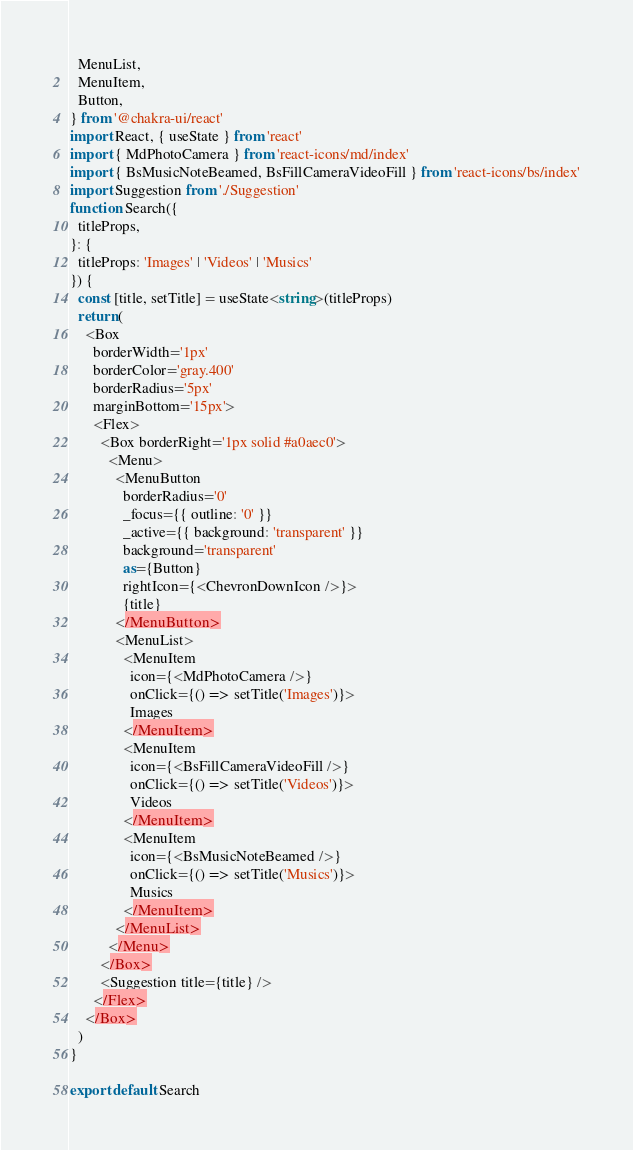<code> <loc_0><loc_0><loc_500><loc_500><_TypeScript_>  MenuList,
  MenuItem,
  Button,
} from '@chakra-ui/react'
import React, { useState } from 'react'
import { MdPhotoCamera } from 'react-icons/md/index'
import { BsMusicNoteBeamed, BsFillCameraVideoFill } from 'react-icons/bs/index'
import Suggestion from './Suggestion'
function Search({
  titleProps,
}: {
  titleProps: 'Images' | 'Videos' | 'Musics'
}) {
  const [title, setTitle] = useState<string>(titleProps)
  return (
    <Box
      borderWidth='1px'
      borderColor='gray.400'
      borderRadius='5px'
      marginBottom='15px'>
      <Flex>
        <Box borderRight='1px solid #a0aec0'>
          <Menu>
            <MenuButton
              borderRadius='0'
              _focus={{ outline: '0' }}
              _active={{ background: 'transparent' }}
              background='transparent'
              as={Button}
              rightIcon={<ChevronDownIcon />}>
              {title}
            </MenuButton>
            <MenuList>
              <MenuItem
                icon={<MdPhotoCamera />}
                onClick={() => setTitle('Images')}>
                Images
              </MenuItem>
              <MenuItem
                icon={<BsFillCameraVideoFill />}
                onClick={() => setTitle('Videos')}>
                Videos
              </MenuItem>
              <MenuItem
                icon={<BsMusicNoteBeamed />}
                onClick={() => setTitle('Musics')}>
                Musics
              </MenuItem>
            </MenuList>
          </Menu>
        </Box>
        <Suggestion title={title} />
      </Flex>
    </Box>
  )
}

export default Search
</code> 